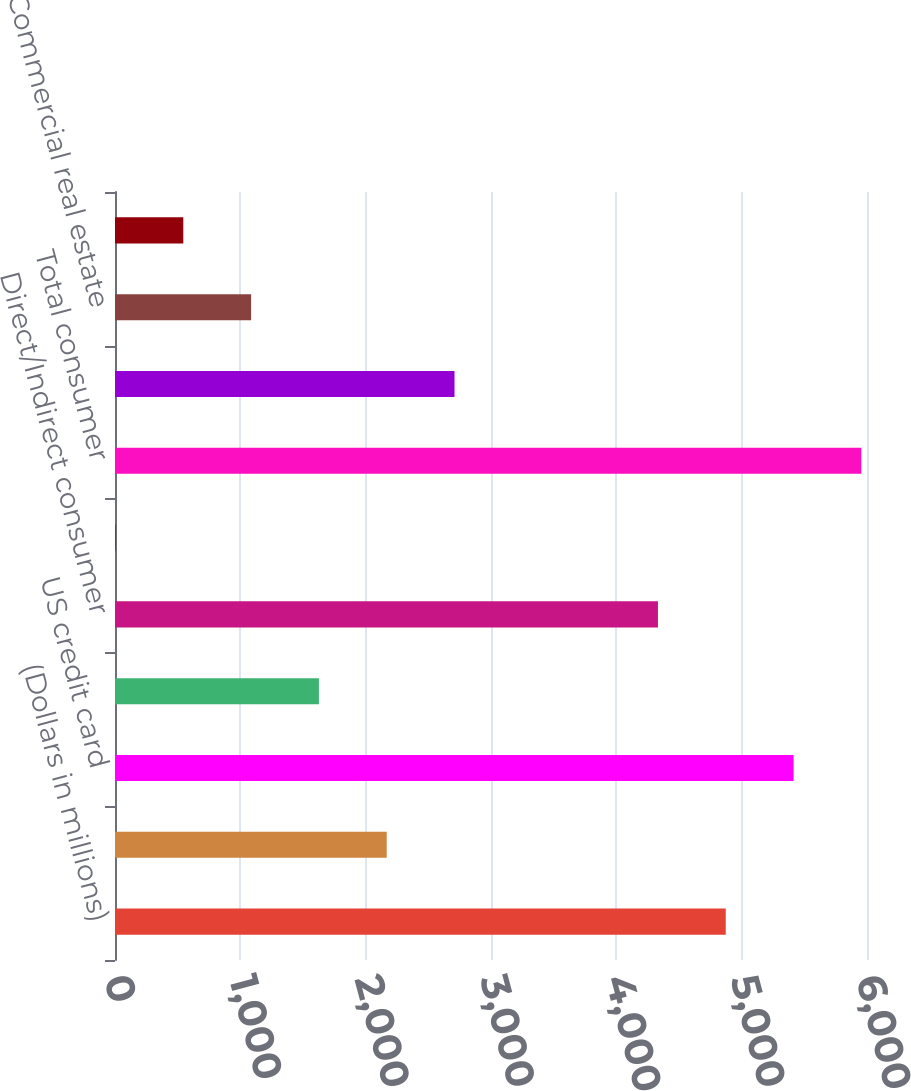<chart> <loc_0><loc_0><loc_500><loc_500><bar_chart><fcel>(Dollars in millions)<fcel>Residential mortgage (2)<fcel>US credit card<fcel>Non-US credit card<fcel>Direct/Indirect consumer<fcel>Other consumer<fcel>Total consumer<fcel>US commercial<fcel>Commercial real estate<fcel>Commercial lease financing<nl><fcel>4873<fcel>2168<fcel>5414<fcel>1627<fcel>4332<fcel>4<fcel>5955<fcel>2709<fcel>1086<fcel>545<nl></chart> 